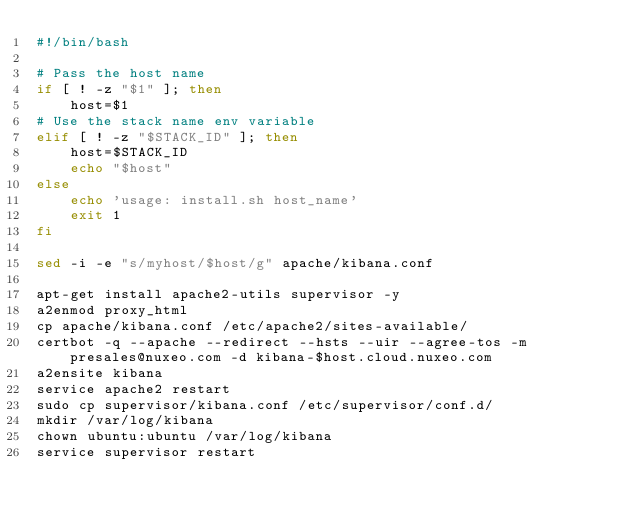<code> <loc_0><loc_0><loc_500><loc_500><_Bash_>#!/bin/bash

# Pass the host name
if [ ! -z "$1" ]; then
    host=$1
# Use the stack name env variable
elif [ ! -z "$STACK_ID" ]; then
    host=$STACK_ID
    echo "$host"
else
    echo 'usage: install.sh host_name'
    exit 1
fi

sed -i -e "s/myhost/$host/g" apache/kibana.conf

apt-get install apache2-utils supervisor -y
a2enmod proxy_html
cp apache/kibana.conf /etc/apache2/sites-available/
certbot -q --apache --redirect --hsts --uir --agree-tos -m presales@nuxeo.com -d kibana-$host.cloud.nuxeo.com
a2ensite kibana
service apache2 restart
sudo cp supervisor/kibana.conf /etc/supervisor/conf.d/
mkdir /var/log/kibana
chown ubuntu:ubuntu /var/log/kibana
service supervisor restart
</code> 